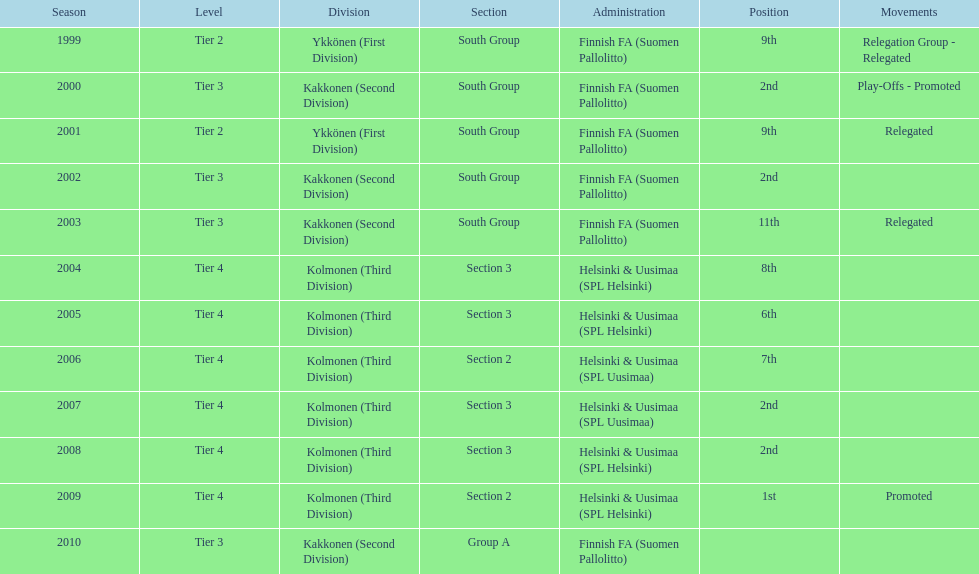Of the third division, how many were in section3? 4. 